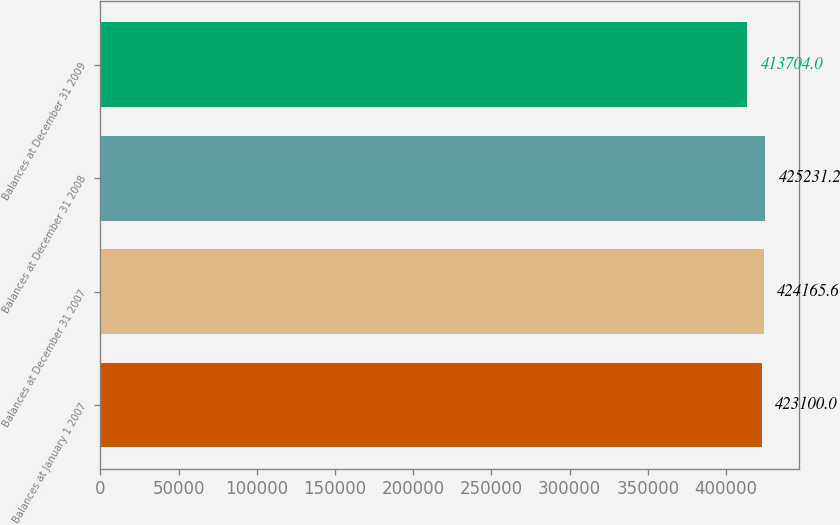Convert chart. <chart><loc_0><loc_0><loc_500><loc_500><bar_chart><fcel>Balances at January 1 2007<fcel>Balances at December 31 2007<fcel>Balances at December 31 2008<fcel>Balances at December 31 2009<nl><fcel>423100<fcel>424166<fcel>425231<fcel>413704<nl></chart> 